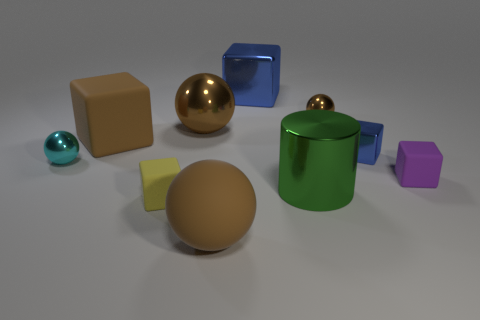There is a ball that is both in front of the big brown metal sphere and right of the large rubber block; what is its color?
Offer a very short reply. Brown. How many other objects are the same size as the green metallic thing?
Your answer should be very brief. 4. There is a purple matte cube; is its size the same as the blue block that is behind the small blue block?
Your answer should be compact. No. There is another matte thing that is the same size as the yellow object; what color is it?
Make the answer very short. Purple. The purple rubber thing has what size?
Offer a very short reply. Small. Does the blue block in front of the big brown metal thing have the same material as the cyan ball?
Make the answer very short. Yes. Is the large green shiny object the same shape as the small blue thing?
Keep it short and to the point. No. What shape is the blue thing behind the big brown matte block behind the block in front of the large green cylinder?
Make the answer very short. Cube. There is a big brown object that is in front of the big green metal thing; does it have the same shape as the object on the right side of the small blue cube?
Your response must be concise. No. Is there a small cyan object made of the same material as the cylinder?
Ensure brevity in your answer.  Yes. 